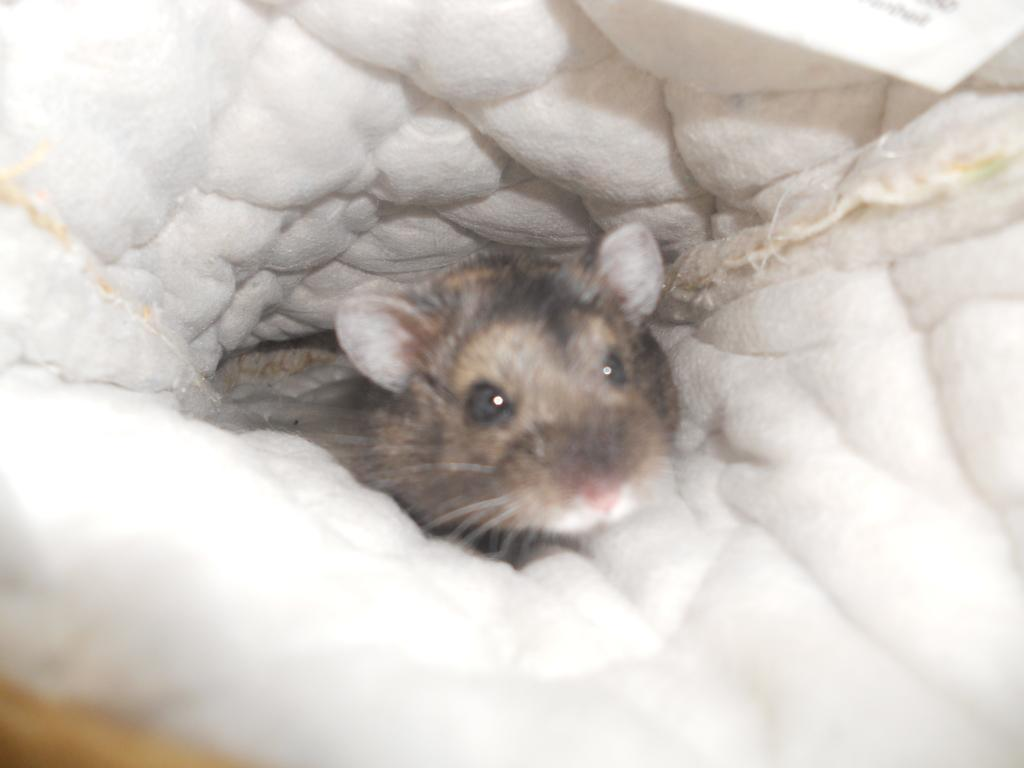What animal is located in the middle of the image? There is a rat in the middle of the image. What color can be seen in the background of the image? There is a white color visible in the background of the image. Where is the jail located in the image? There is no jail present in the image. What type of discussion is taking place between the rat and the background? There is no discussion taking place in the image, as the rat and the background are inanimate objects. 